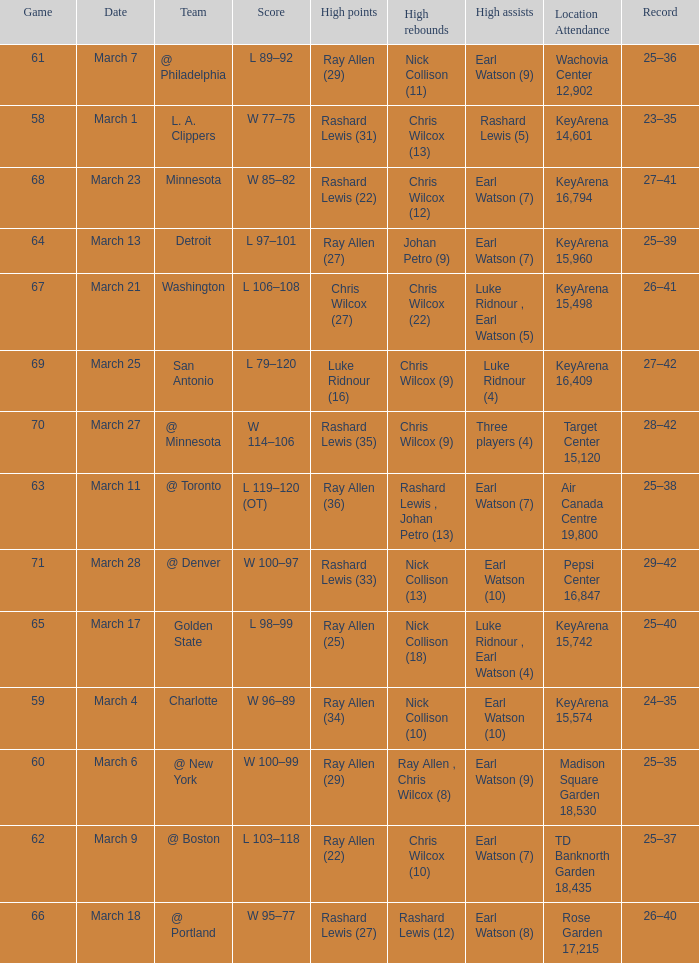What was the record after the game against Washington? 26–41. 